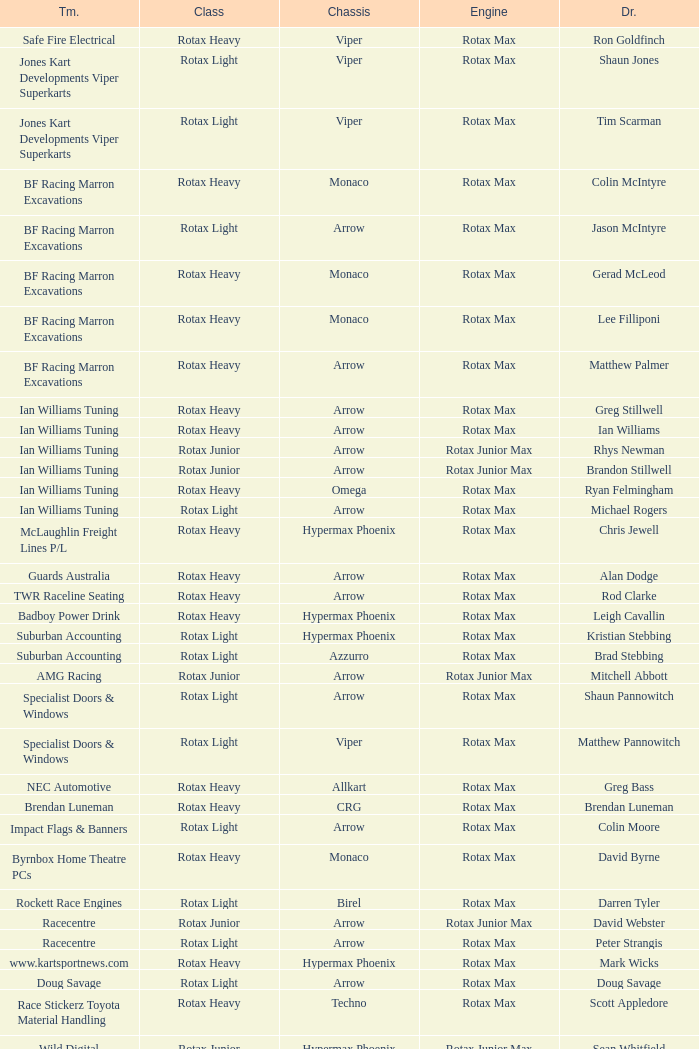What is the name of the driver with a rotax max engine, in the rotax heavy class, with arrow as chassis and on the TWR Raceline Seating team? Rod Clarke. 